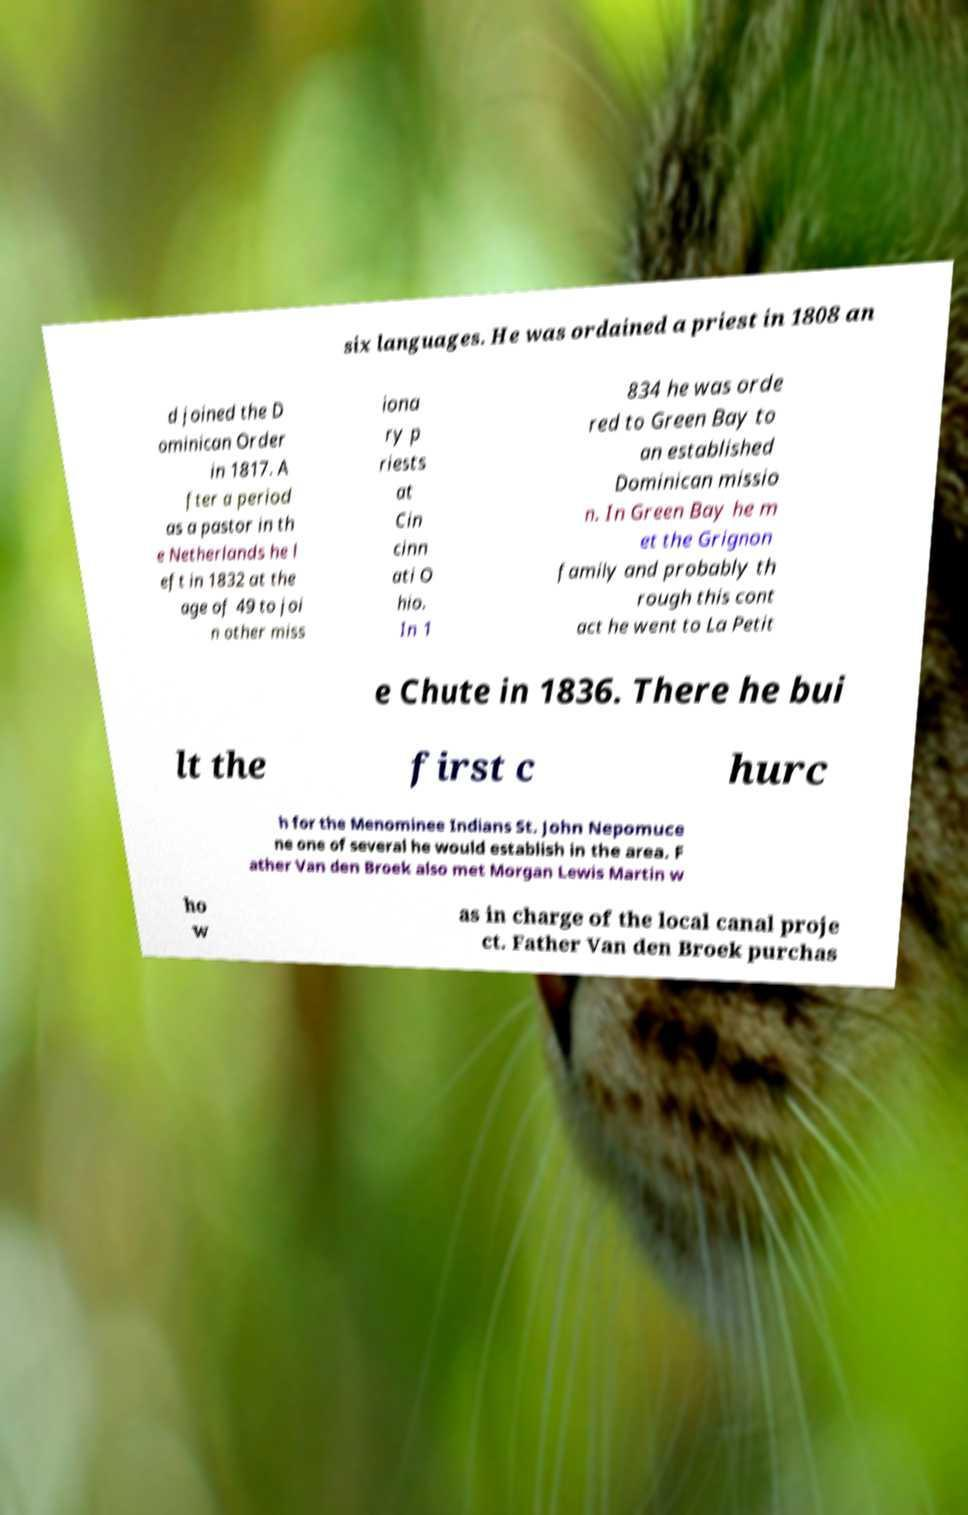Could you extract and type out the text from this image? six languages. He was ordained a priest in 1808 an d joined the D ominican Order in 1817. A fter a period as a pastor in th e Netherlands he l eft in 1832 at the age of 49 to joi n other miss iona ry p riests at Cin cinn ati O hio. In 1 834 he was orde red to Green Bay to an established Dominican missio n. In Green Bay he m et the Grignon family and probably th rough this cont act he went to La Petit e Chute in 1836. There he bui lt the first c hurc h for the Menominee Indians St. John Nepomuce ne one of several he would establish in the area. F ather Van den Broek also met Morgan Lewis Martin w ho w as in charge of the local canal proje ct. Father Van den Broek purchas 